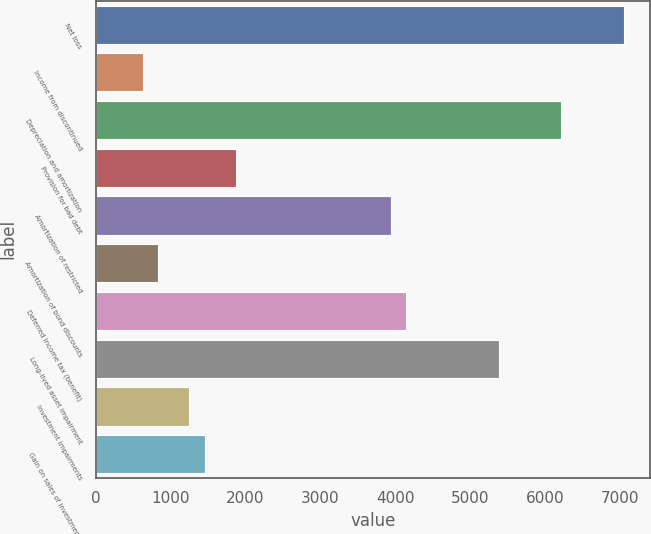<chart> <loc_0><loc_0><loc_500><loc_500><bar_chart><fcel>Net loss<fcel>Income from discontinued<fcel>Depreciation and amortization<fcel>Provision for bad debt<fcel>Amortization of restricted<fcel>Amortization of bond discounts<fcel>Deferred income tax (benefit)<fcel>Long-lived asset impairment<fcel>Investment impairments<fcel>Gain on sales of investments<nl><fcel>7050.38<fcel>625.01<fcel>6221.3<fcel>1868.63<fcel>3941.33<fcel>832.28<fcel>4148.6<fcel>5392.22<fcel>1246.82<fcel>1454.09<nl></chart> 